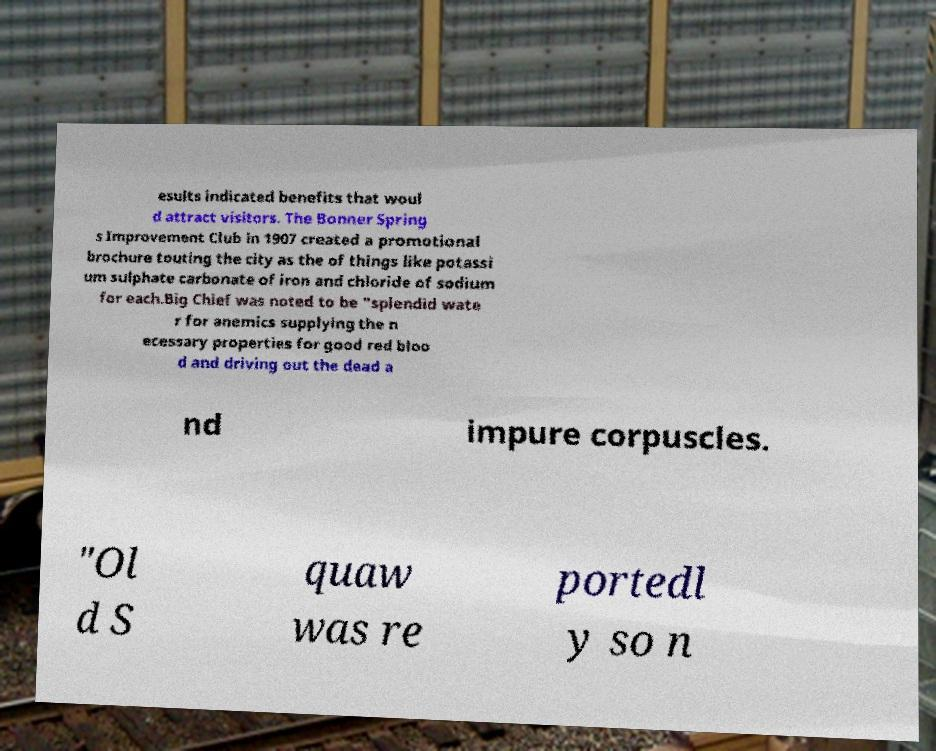What messages or text are displayed in this image? I need them in a readable, typed format. esults indicated benefits that woul d attract visitors. The Bonner Spring s Improvement Club in 1907 created a promotional brochure touting the city as the of things like potassi um sulphate carbonate of iron and chloride of sodium for each.Big Chief was noted to be "splendid wate r for anemics supplying the n ecessary properties for good red bloo d and driving out the dead a nd impure corpuscles. "Ol d S quaw was re portedl y so n 